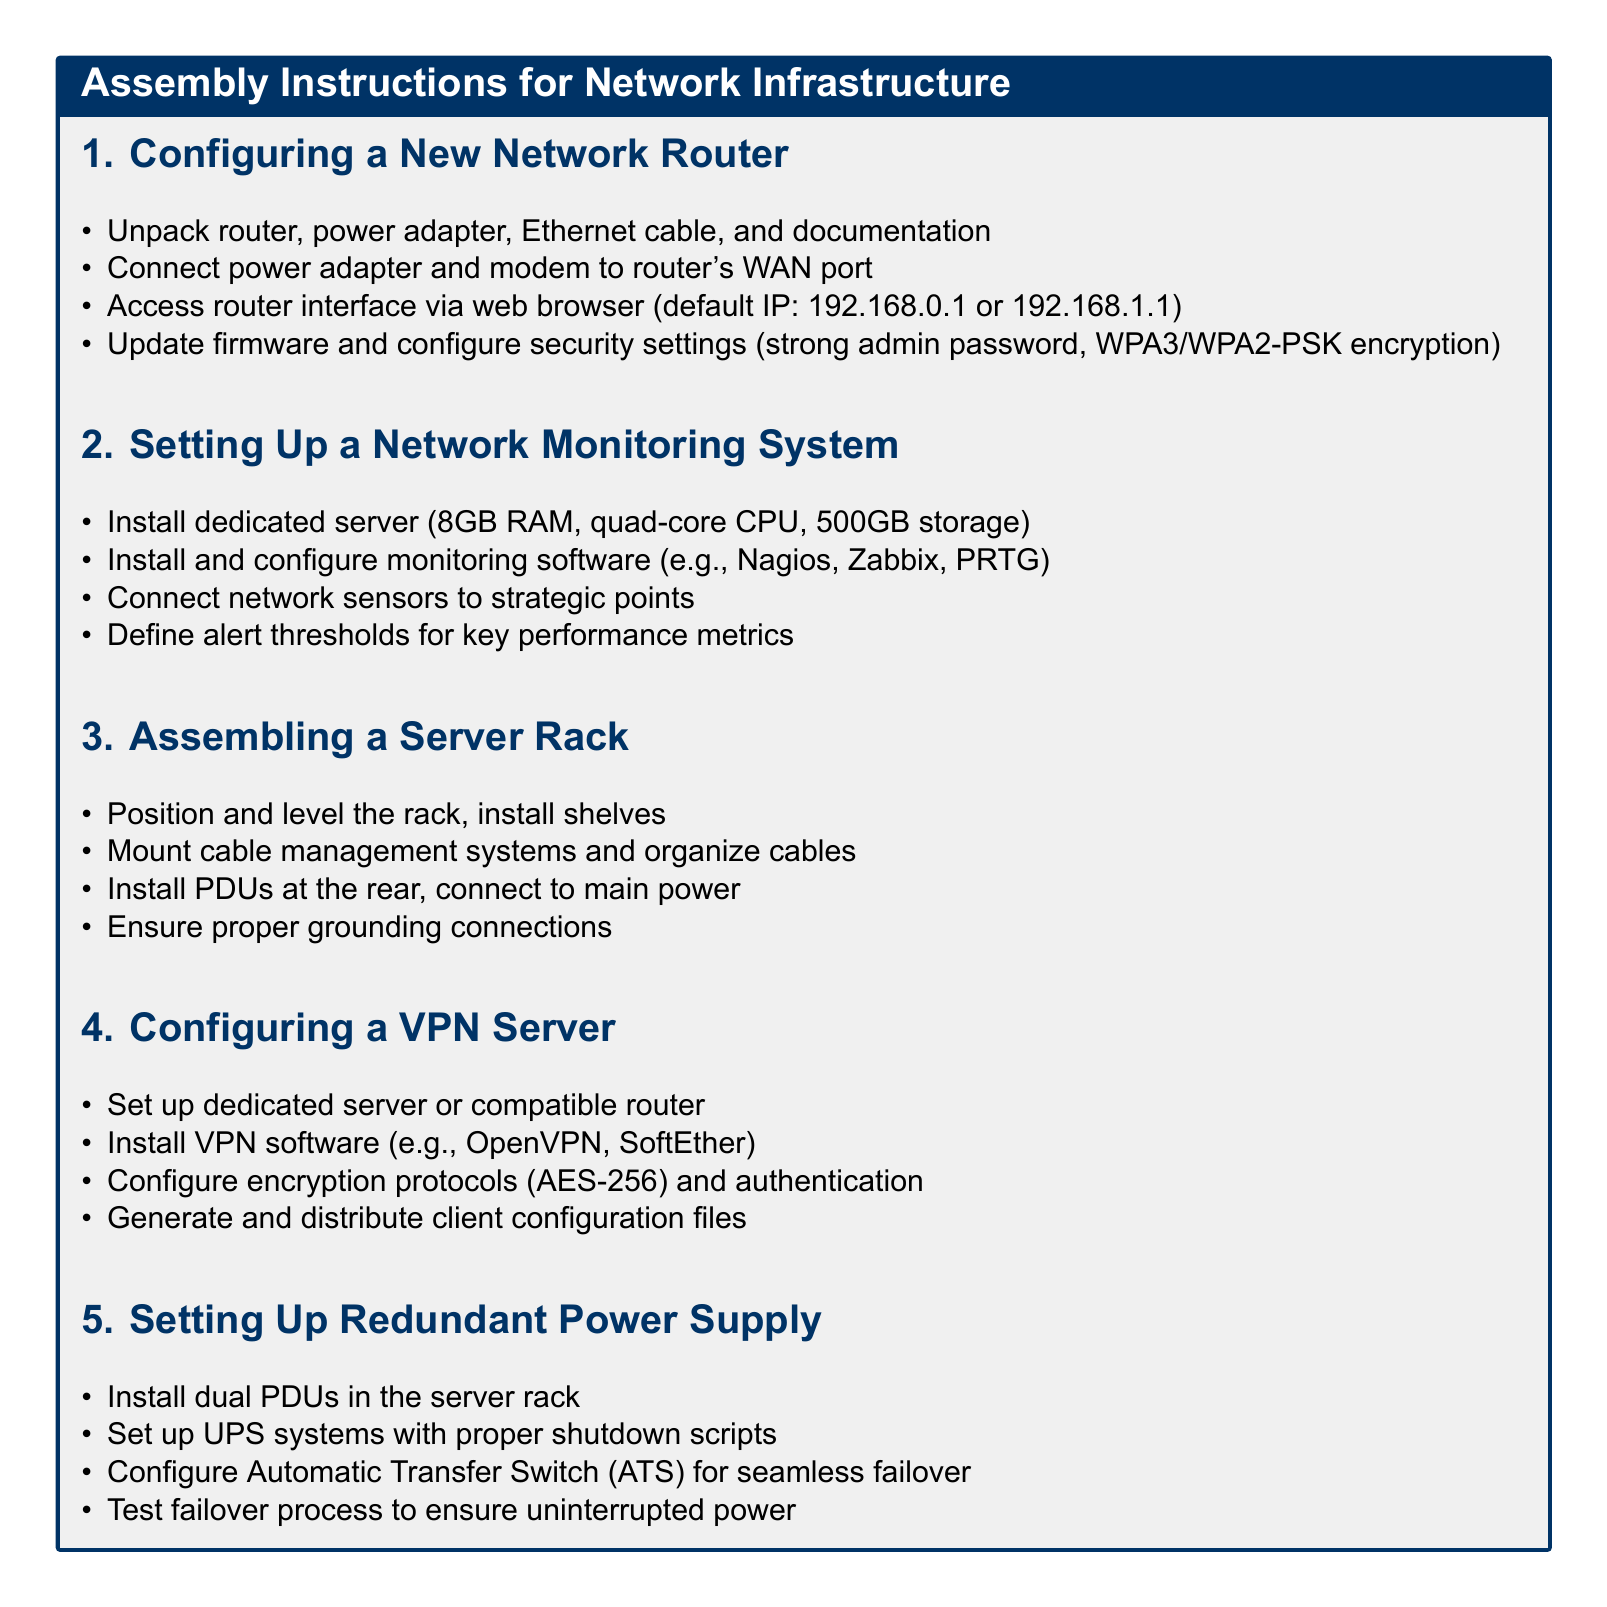What is the default IP for the router interface? The document specifies the default IP for accessing the router interface as 192.168.0.1 or 192.168.1.1.
Answer: 192.168.0.1 or 192.168.1.1 How much RAM is required for the dedicated server in the network monitoring system? The assembly instructions specify that the dedicated server needs 8GB RAM for the network monitoring system.
Answer: 8GB RAM What software can be used for configuring a VPN server? The document mentions OpenVPN and SoftEther as examples of VPN software that can be installed for configuring a VPN server.
Answer: OpenVPN, SoftEther What must be done before ensuring proper grounding connections in the server rack? The instructions indicate that before ensuring proper grounding connections, one must install PDUs at the rear and connect them to the main power.
Answer: Install PDUs and connect to main power What is the encryption protocol recommended for a VPN server? The document recommends AES-256 as the encryption protocol for the VPN server configuration.
Answer: AES-256 How many PDUs are installed for a redundant power supply system? The assembly instructions for the redundant power supply system state that dual PDUs should be installed in the server rack.
Answer: Dual PDUs Why is it important to test the failover process? The document indicates that testing the failover process is crucial to ensure uninterrupted power.
Answer: Uninterrupted power What should be done after connecting the power adapter and modem to the router? Following the connection of the power adapter and modem to the router, one needs to access the router interface via a web browser.
Answer: Access router interface 